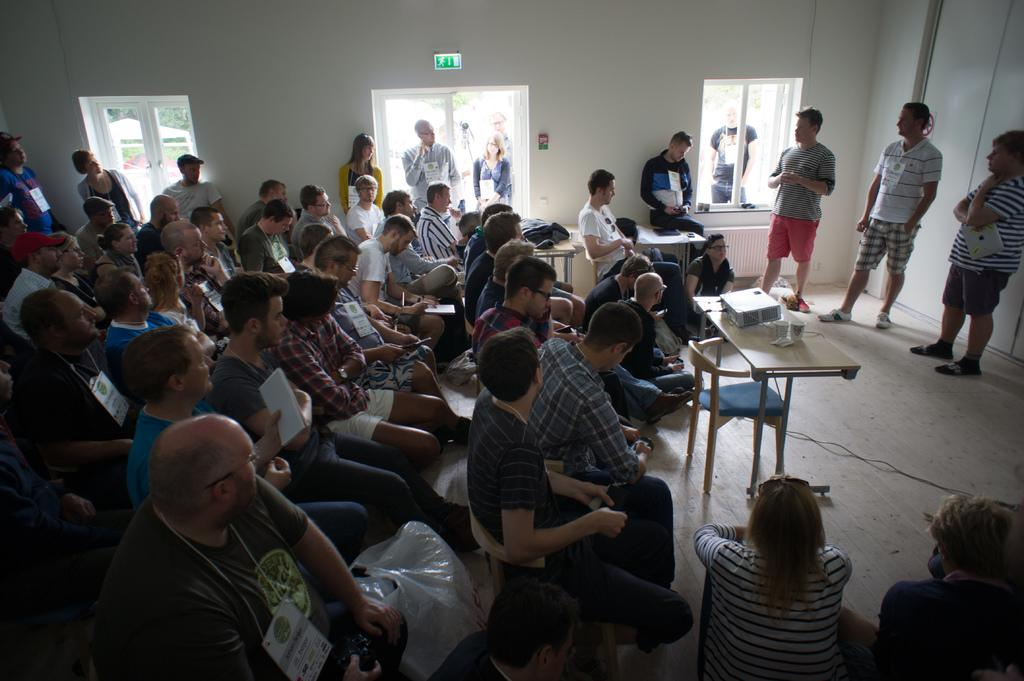What are the people in the image wearing? The persons in the image are wearing clothes. What are the people doing in the image? Some persons are sitting on chairs. What objects can be seen in the middle of the image? There are tables in the middle of the image. What can be seen at the top of the image? There are windows at the top of the image. What type of battle is taking place in the image? There is no battle present in the image; it features persons sitting on chairs and tables. What is the sun's position in the image? The provided facts do not mention the sun's position, as the focus is on the persons, chairs, tables, and windows. 